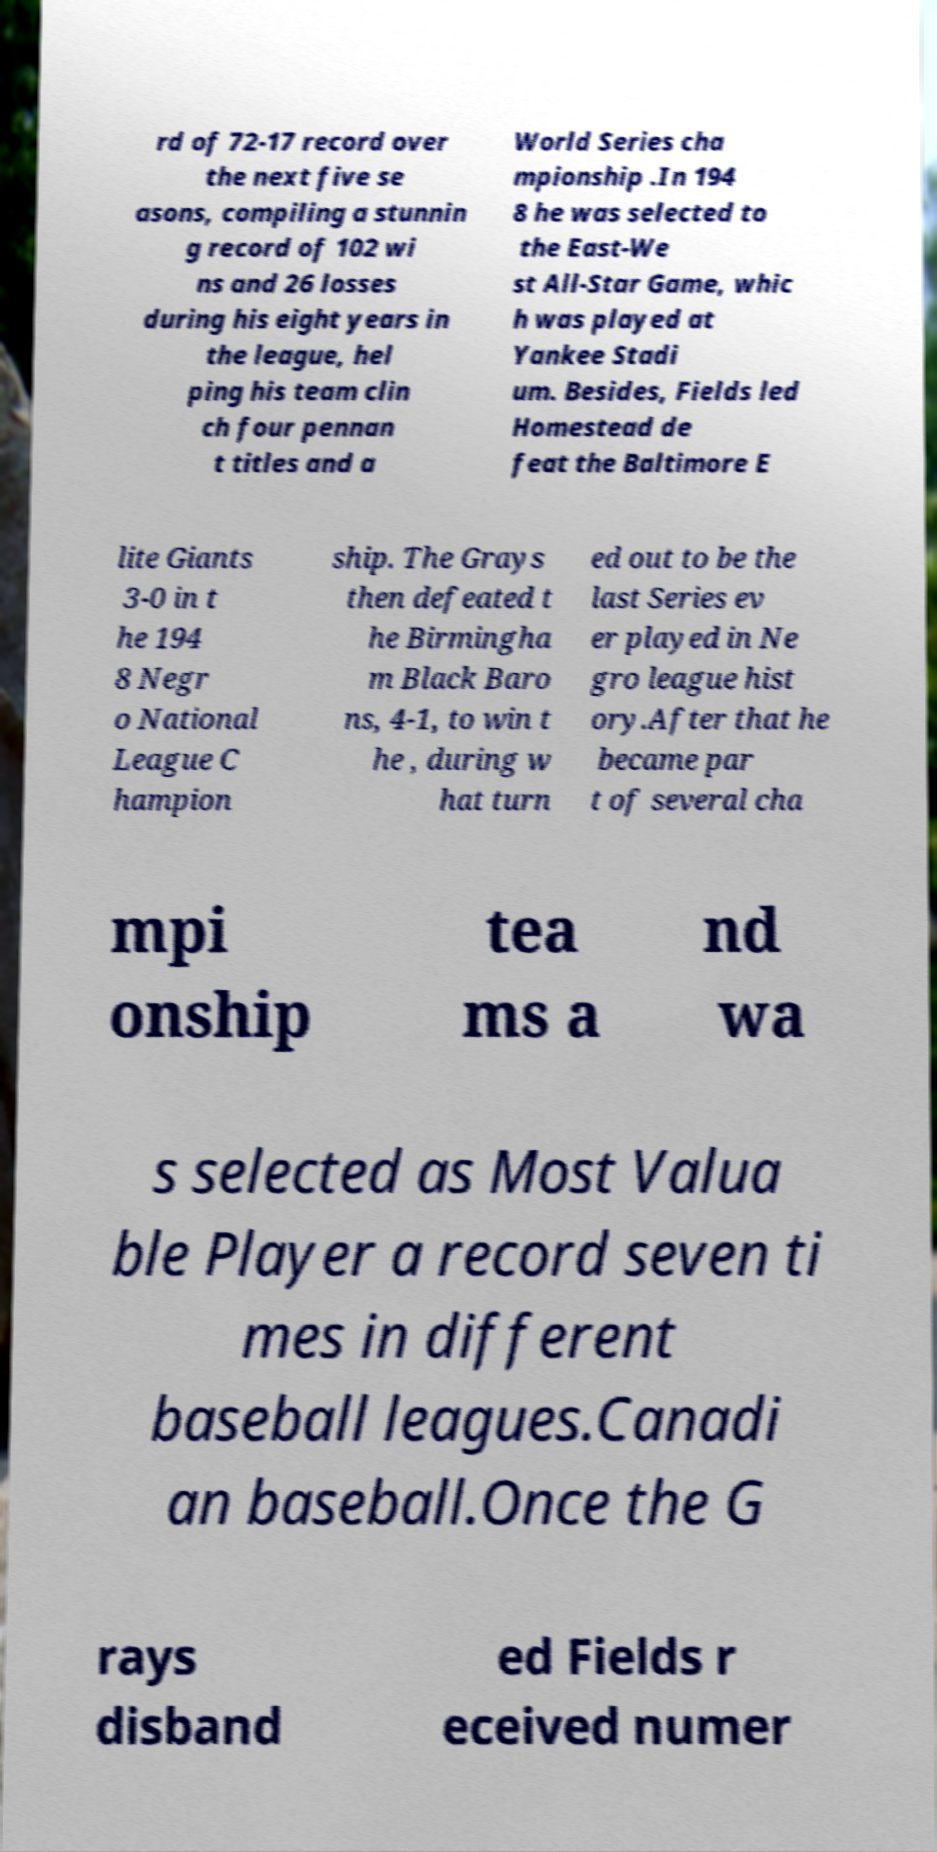I need the written content from this picture converted into text. Can you do that? rd of 72-17 record over the next five se asons, compiling a stunnin g record of 102 wi ns and 26 losses during his eight years in the league, hel ping his team clin ch four pennan t titles and a World Series cha mpionship .In 194 8 he was selected to the East-We st All-Star Game, whic h was played at Yankee Stadi um. Besides, Fields led Homestead de feat the Baltimore E lite Giants 3-0 in t he 194 8 Negr o National League C hampion ship. The Grays then defeated t he Birmingha m Black Baro ns, 4-1, to win t he , during w hat turn ed out to be the last Series ev er played in Ne gro league hist ory.After that he became par t of several cha mpi onship tea ms a nd wa s selected as Most Valua ble Player a record seven ti mes in different baseball leagues.Canadi an baseball.Once the G rays disband ed Fields r eceived numer 